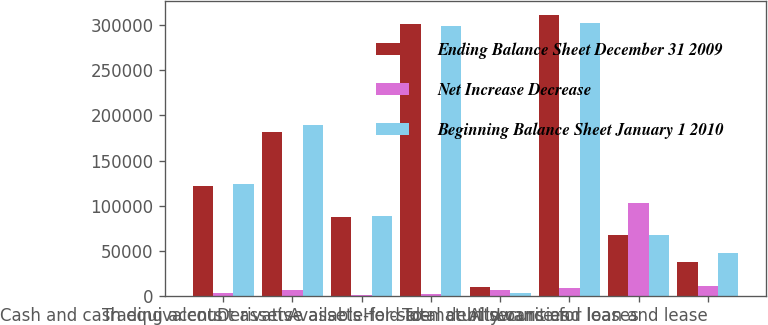<chart> <loc_0><loc_0><loc_500><loc_500><stacked_bar_chart><ecel><fcel>Cash and cash equivalents<fcel>Trading account assets<fcel>Derivative assets<fcel>Available-for-sale<fcel>Held-to-maturity<fcel>Total debt securities<fcel>Loans and leases<fcel>Allowance for loan and lease<nl><fcel>Ending Balance Sheet December 31 2009<fcel>121339<fcel>182206<fcel>87622<fcel>301601<fcel>9840<fcel>311441<fcel>67805<fcel>37200<nl><fcel>Net Increase Decrease<fcel>2807<fcel>6937<fcel>556<fcel>2320<fcel>6572<fcel>8892<fcel>102595<fcel>10788<nl><fcel>Beginning Balance Sheet January 1 2010<fcel>124146<fcel>189143<fcel>88178<fcel>299281<fcel>3268<fcel>302549<fcel>67805<fcel>47988<nl></chart> 